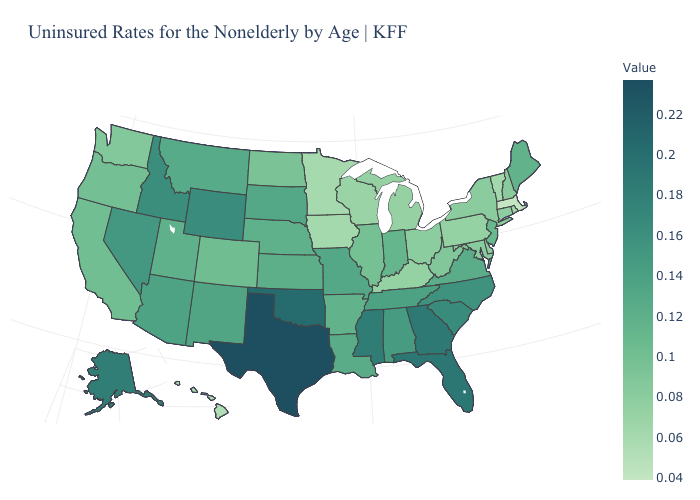Does North Dakota have the lowest value in the MidWest?
Be succinct. No. Does the map have missing data?
Concise answer only. No. Does Hawaii have a lower value than Michigan?
Give a very brief answer. Yes. Does Iowa have the lowest value in the MidWest?
Short answer required. No. Among the states that border South Dakota , which have the lowest value?
Keep it brief. Minnesota. Which states have the lowest value in the Northeast?
Give a very brief answer. Massachusetts. Does Massachusetts have the lowest value in the USA?
Quick response, please. Yes. Does Michigan have the highest value in the MidWest?
Quick response, please. No. Is the legend a continuous bar?
Write a very short answer. Yes. 